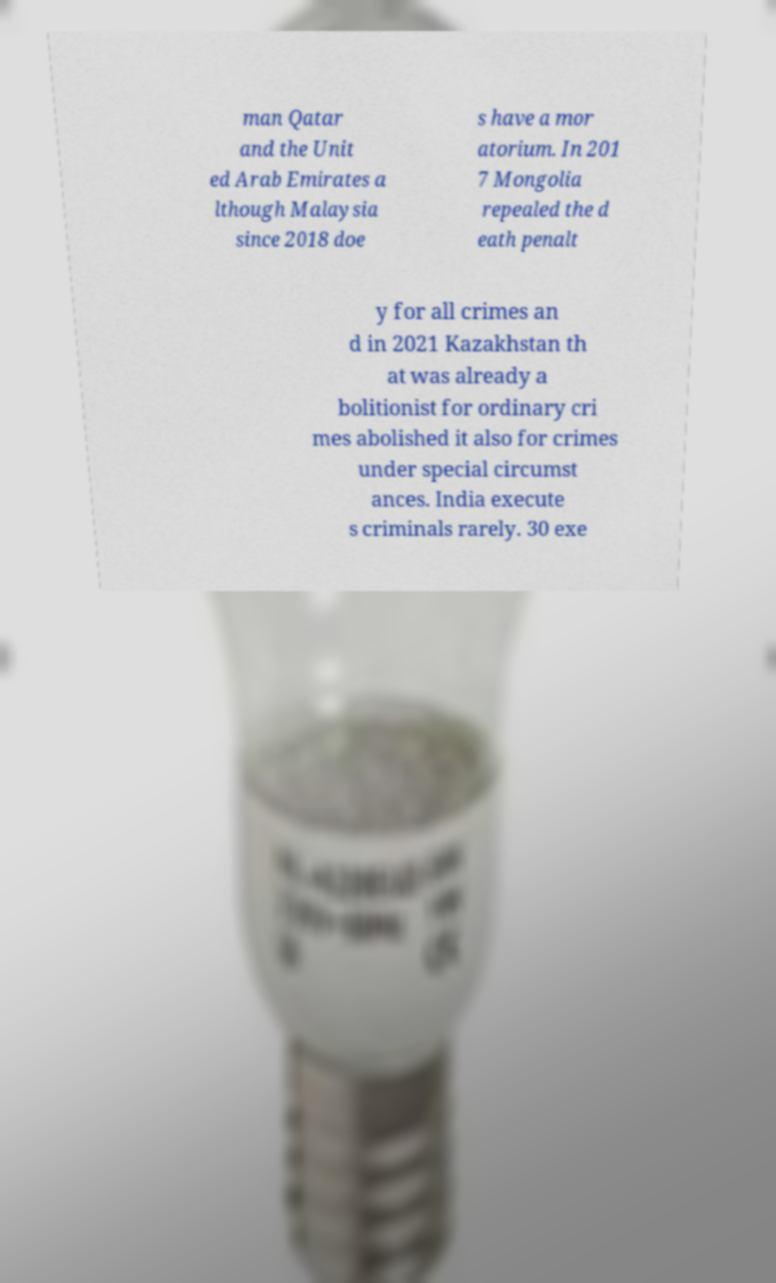Please read and relay the text visible in this image. What does it say? man Qatar and the Unit ed Arab Emirates a lthough Malaysia since 2018 doe s have a mor atorium. In 201 7 Mongolia repealed the d eath penalt y for all crimes an d in 2021 Kazakhstan th at was already a bolitionist for ordinary cri mes abolished it also for crimes under special circumst ances. India execute s criminals rarely. 30 exe 